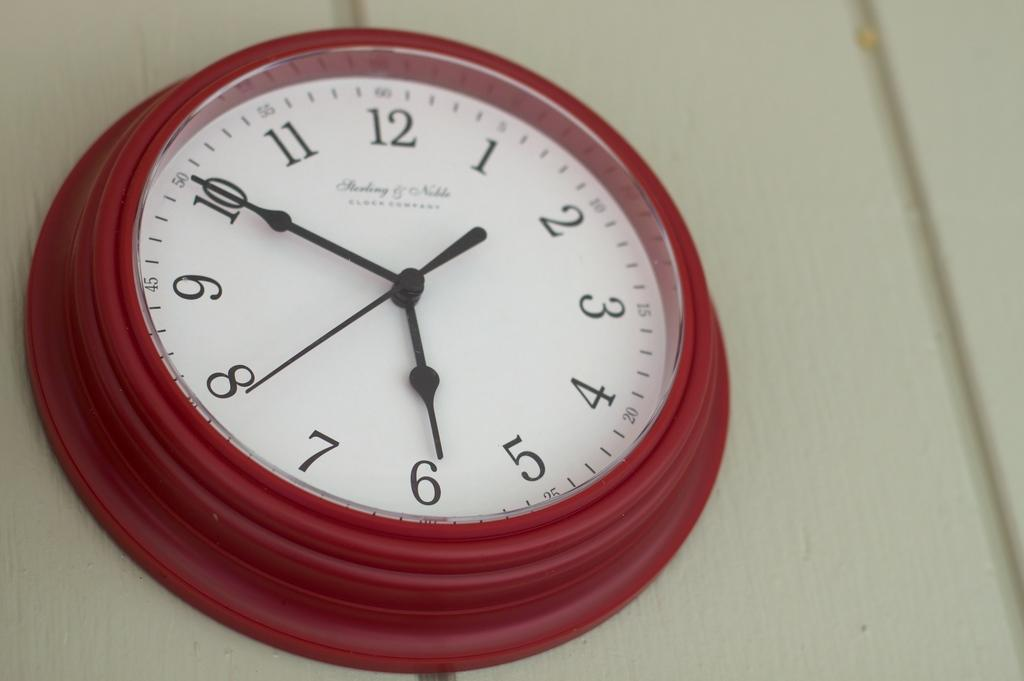<image>
Share a concise interpretation of the image provided. A red wall clock that was manufactured by the clock Sterling and Noble. 